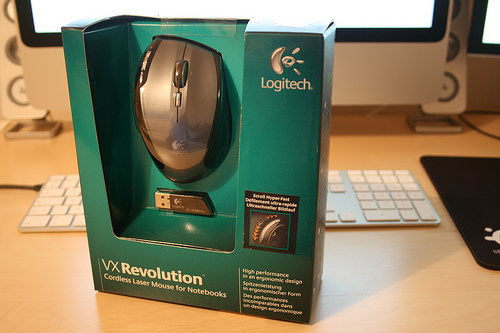<image>
Can you confirm if the mouse is in the box? Yes. The mouse is contained within or inside the box, showing a containment relationship. Is there a mouse above the desk? Yes. The mouse is positioned above the desk in the vertical space, higher up in the scene. 